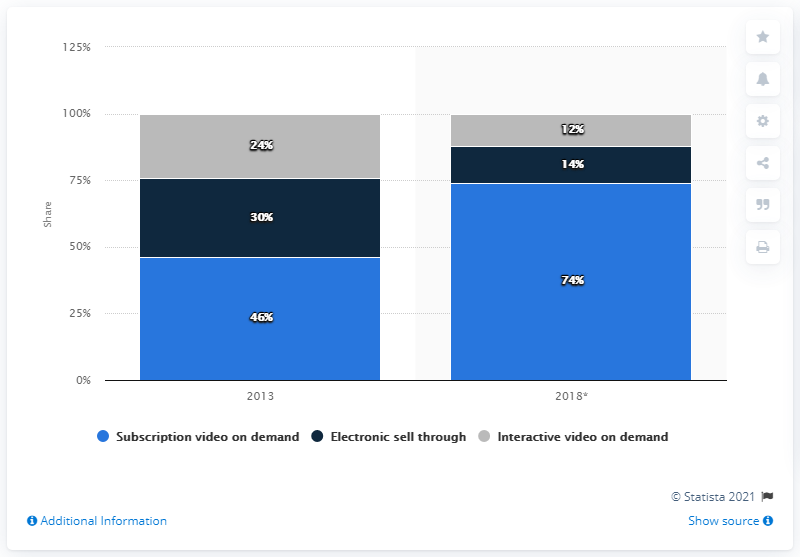List a handful of essential elements in this visual. The second most commonly used distribution method in both years was electronic sell-through. In 2013, over-the-top consumer spending occurred in Western Europe. In 2013, electronic sell-through accounted for approximately 30% of consumer spending. In 2018, the most popular distribution of video on demand was subscription-based. 